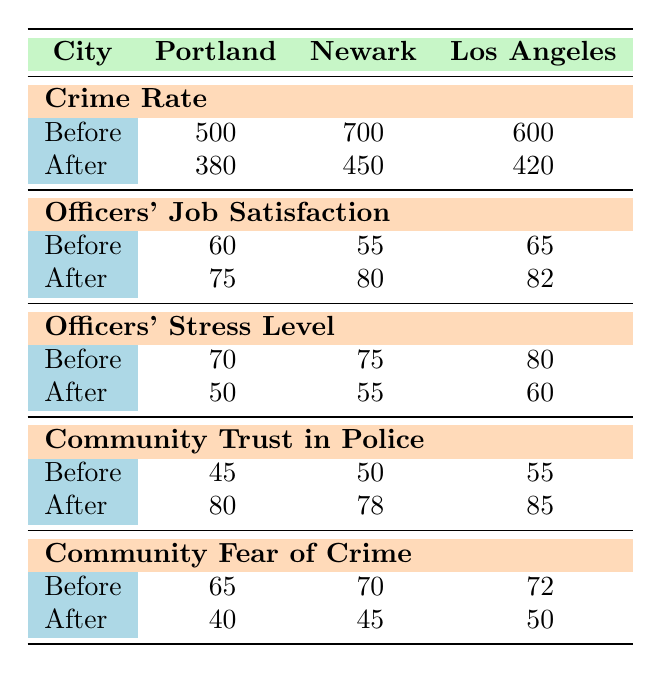What was the crime rate in Portland before implementing community-based policing? The crime rate in Portland before implementing community-based policing is listed in the table under "Crime Rate" and is noted as 500.
Answer: 500 What is the change in officers' job satisfaction in Newark? The job satisfaction for officers before was 55, and after it was 80. The change is calculated by subtracting the before value from the after value: 80 - 55 = 25.
Answer: 25 Did the crime rate decrease in Los Angeles after community-based policing was implemented? The crime rate before was 600 and after it was 420. Since 420 is less than 600, we can conclude that there was a decrease.
Answer: Yes What is the average trust in police before and after community-based policing across all cities? To find the average trust in police before, add the values: (45 + 50 + 55) = 150, then divide by 3 = 50. For after, (80 + 78 + 85) = 243, and divide by 3 = 81.
Answer: Before: 50, After: 81 How much did the fear of crime decrease on average across all cities? First, calculate the fear of crime before: (65 + 70 + 72) = 207, and after: (40 + 45 + 50) = 135. The average decrease is found by taking the total before (207) minus the total after (135) to get 207 - 135 = 72.
Answer: 72 What was the stress level of officers in Portland after community-based policing? The stress level for officers after community-based policing in Portland is listed under "Officers' Stress Level" as 50.
Answer: 50 Is the trust in police after community-based policing higher in Los Angeles than in Newark? In Los Angeles, trust in police after is 85, and in Newark, it is 78. Since 85 is greater than 78, this statement is true.
Answer: Yes What is the total decrease in crime rate across all cities combined? First, sum the crime rates before: (500 + 700 + 600) = 1800, and after: (380 + 450 + 420) = 1250. The total decrease is 1800 - 1250 = 550.
Answer: 550 